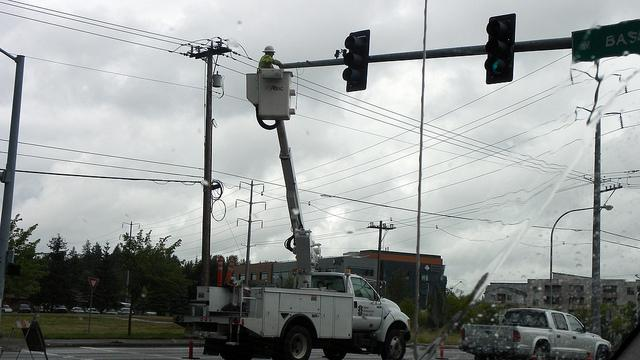What sort of repairs in the lifted person doing? electrical 